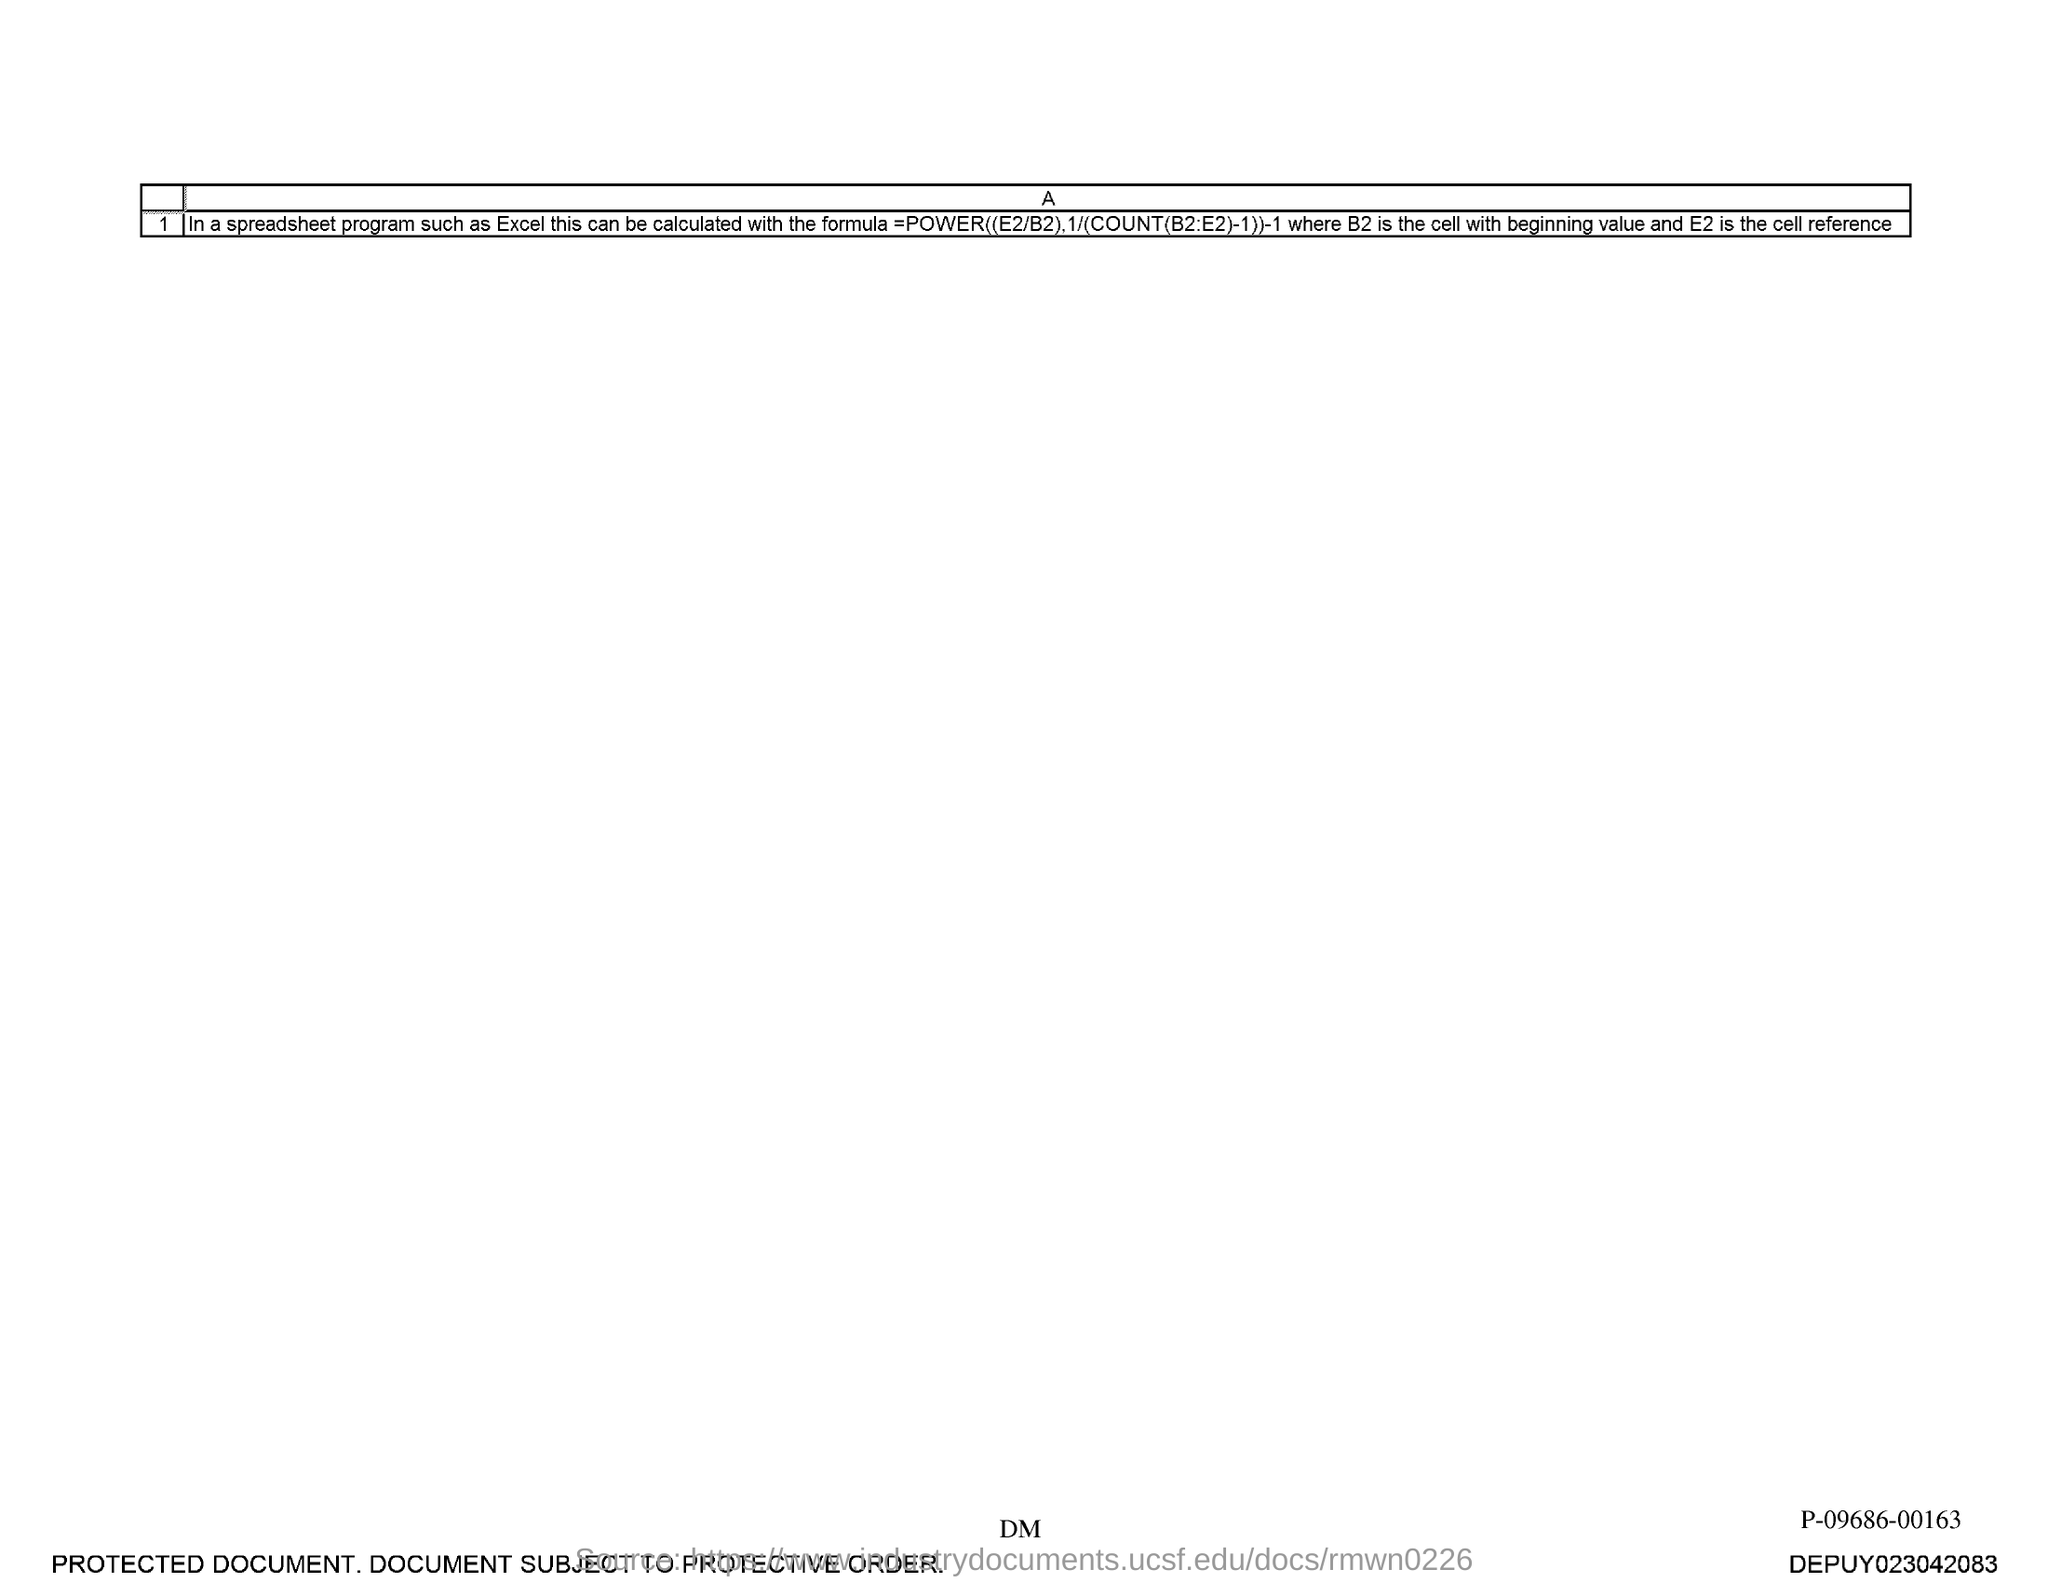Mention a couple of crucial points in this snapshot. E2 is referred to as "Cell Reference" in this document. 